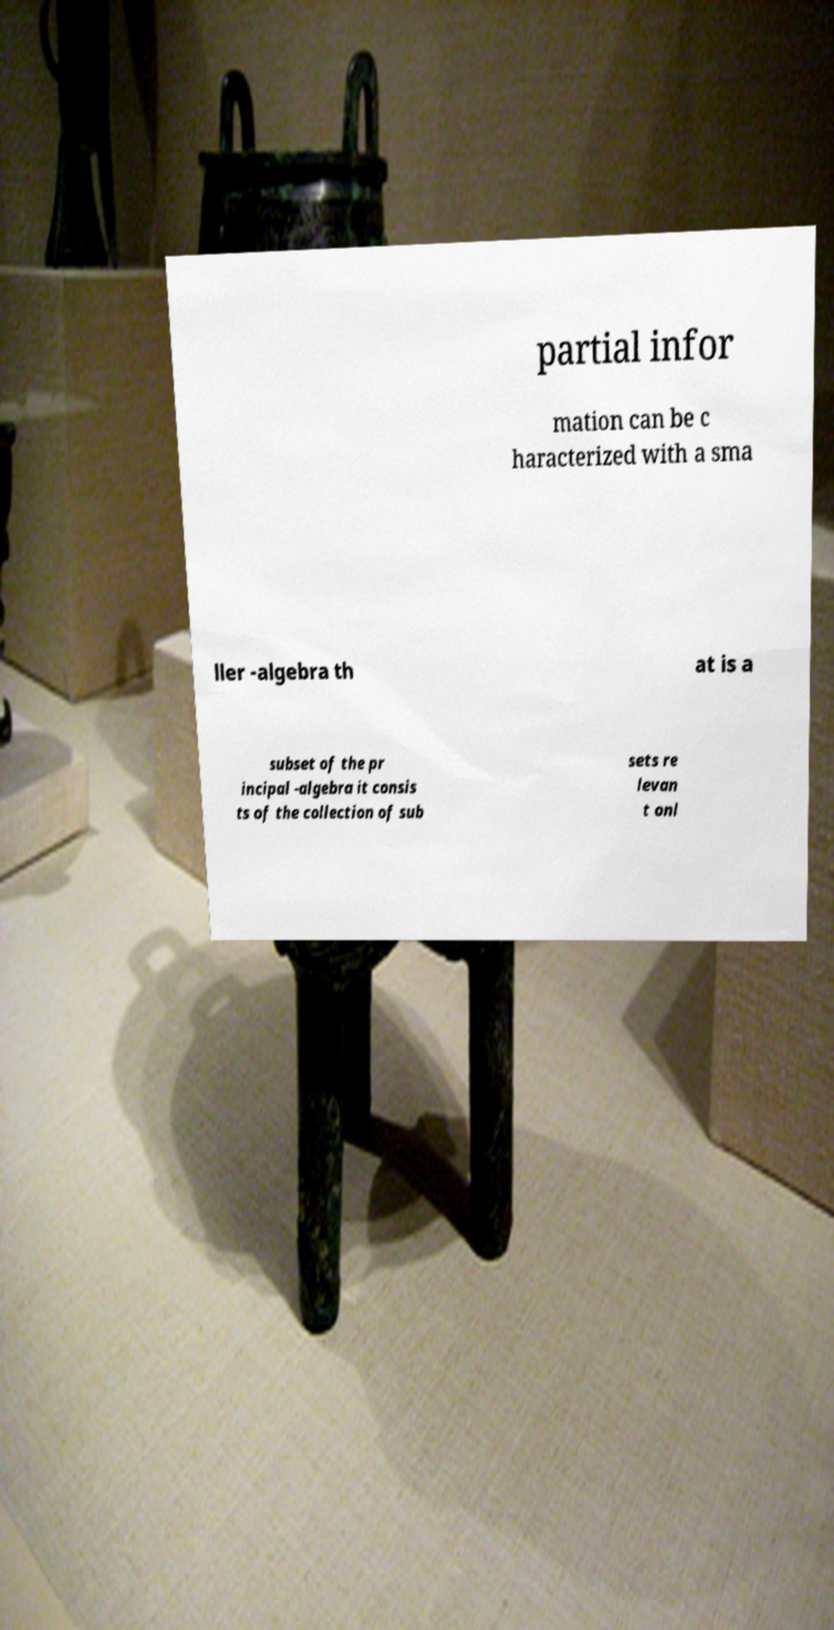Could you extract and type out the text from this image? partial infor mation can be c haracterized with a sma ller -algebra th at is a subset of the pr incipal -algebra it consis ts of the collection of sub sets re levan t onl 